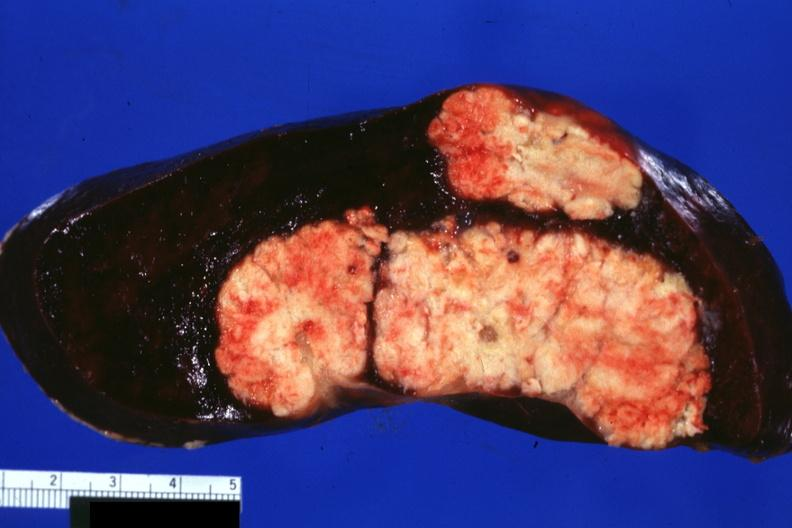what is present?
Answer the question using a single word or phrase. Metastatic colon cancer 